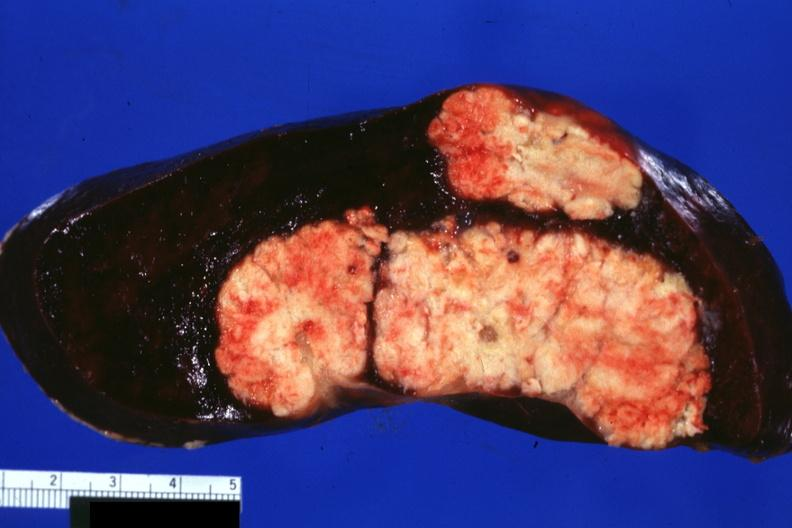what is present?
Answer the question using a single word or phrase. Metastatic colon cancer 